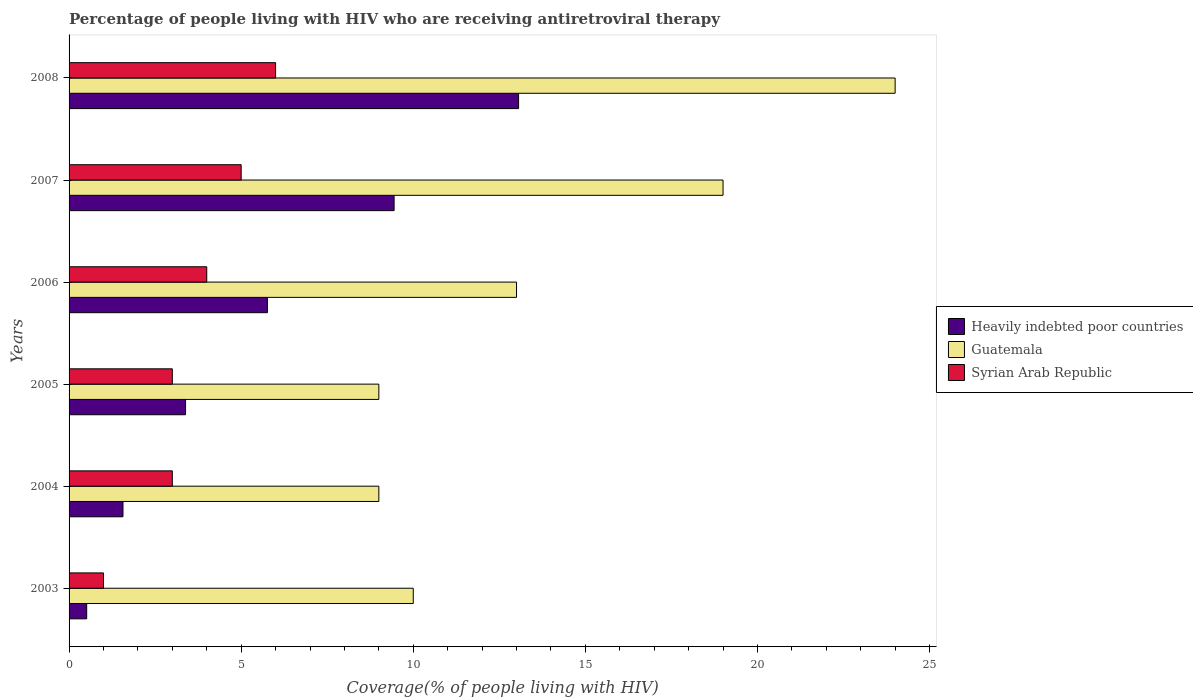How many different coloured bars are there?
Make the answer very short. 3. Are the number of bars per tick equal to the number of legend labels?
Ensure brevity in your answer.  Yes. Are the number of bars on each tick of the Y-axis equal?
Provide a succinct answer. Yes. How many bars are there on the 3rd tick from the top?
Your answer should be compact. 3. In how many cases, is the number of bars for a given year not equal to the number of legend labels?
Offer a terse response. 0. What is the percentage of the HIV infected people who are receiving antiretroviral therapy in Guatemala in 2004?
Keep it short and to the point. 9. Across all years, what is the maximum percentage of the HIV infected people who are receiving antiretroviral therapy in Heavily indebted poor countries?
Keep it short and to the point. 13.06. Across all years, what is the minimum percentage of the HIV infected people who are receiving antiretroviral therapy in Heavily indebted poor countries?
Offer a terse response. 0.51. In which year was the percentage of the HIV infected people who are receiving antiretroviral therapy in Heavily indebted poor countries maximum?
Your answer should be compact. 2008. What is the total percentage of the HIV infected people who are receiving antiretroviral therapy in Syrian Arab Republic in the graph?
Ensure brevity in your answer.  22. What is the difference between the percentage of the HIV infected people who are receiving antiretroviral therapy in Syrian Arab Republic in 2003 and that in 2004?
Offer a very short reply. -2. What is the difference between the percentage of the HIV infected people who are receiving antiretroviral therapy in Guatemala in 2005 and the percentage of the HIV infected people who are receiving antiretroviral therapy in Syrian Arab Republic in 2003?
Your answer should be very brief. 8. What is the average percentage of the HIV infected people who are receiving antiretroviral therapy in Guatemala per year?
Your answer should be compact. 14. In the year 2003, what is the difference between the percentage of the HIV infected people who are receiving antiretroviral therapy in Heavily indebted poor countries and percentage of the HIV infected people who are receiving antiretroviral therapy in Guatemala?
Offer a very short reply. -9.49. In how many years, is the percentage of the HIV infected people who are receiving antiretroviral therapy in Syrian Arab Republic greater than 21 %?
Your response must be concise. 0. What is the ratio of the percentage of the HIV infected people who are receiving antiretroviral therapy in Guatemala in 2006 to that in 2008?
Provide a short and direct response. 0.54. Is the percentage of the HIV infected people who are receiving antiretroviral therapy in Guatemala in 2003 less than that in 2008?
Offer a terse response. Yes. What is the difference between the highest and the second highest percentage of the HIV infected people who are receiving antiretroviral therapy in Heavily indebted poor countries?
Provide a succinct answer. 3.62. What is the difference between the highest and the lowest percentage of the HIV infected people who are receiving antiretroviral therapy in Syrian Arab Republic?
Provide a succinct answer. 5. What does the 1st bar from the top in 2005 represents?
Your response must be concise. Syrian Arab Republic. What does the 1st bar from the bottom in 2004 represents?
Ensure brevity in your answer.  Heavily indebted poor countries. Is it the case that in every year, the sum of the percentage of the HIV infected people who are receiving antiretroviral therapy in Syrian Arab Republic and percentage of the HIV infected people who are receiving antiretroviral therapy in Heavily indebted poor countries is greater than the percentage of the HIV infected people who are receiving antiretroviral therapy in Guatemala?
Make the answer very short. No. How many bars are there?
Provide a succinct answer. 18. Are all the bars in the graph horizontal?
Give a very brief answer. Yes. How many years are there in the graph?
Ensure brevity in your answer.  6. Are the values on the major ticks of X-axis written in scientific E-notation?
Offer a terse response. No. How many legend labels are there?
Provide a succinct answer. 3. What is the title of the graph?
Offer a terse response. Percentage of people living with HIV who are receiving antiretroviral therapy. Does "Paraguay" appear as one of the legend labels in the graph?
Keep it short and to the point. No. What is the label or title of the X-axis?
Your answer should be very brief. Coverage(% of people living with HIV). What is the Coverage(% of people living with HIV) in Heavily indebted poor countries in 2003?
Provide a short and direct response. 0.51. What is the Coverage(% of people living with HIV) of Syrian Arab Republic in 2003?
Offer a terse response. 1. What is the Coverage(% of people living with HIV) of Heavily indebted poor countries in 2004?
Provide a short and direct response. 1.57. What is the Coverage(% of people living with HIV) in Syrian Arab Republic in 2004?
Your answer should be very brief. 3. What is the Coverage(% of people living with HIV) of Heavily indebted poor countries in 2005?
Provide a succinct answer. 3.38. What is the Coverage(% of people living with HIV) in Guatemala in 2005?
Give a very brief answer. 9. What is the Coverage(% of people living with HIV) of Heavily indebted poor countries in 2006?
Keep it short and to the point. 5.76. What is the Coverage(% of people living with HIV) in Guatemala in 2006?
Provide a short and direct response. 13. What is the Coverage(% of people living with HIV) in Syrian Arab Republic in 2006?
Provide a succinct answer. 4. What is the Coverage(% of people living with HIV) in Heavily indebted poor countries in 2007?
Provide a short and direct response. 9.44. What is the Coverage(% of people living with HIV) of Guatemala in 2007?
Your answer should be compact. 19. What is the Coverage(% of people living with HIV) in Heavily indebted poor countries in 2008?
Give a very brief answer. 13.06. What is the Coverage(% of people living with HIV) in Guatemala in 2008?
Make the answer very short. 24. Across all years, what is the maximum Coverage(% of people living with HIV) of Heavily indebted poor countries?
Provide a short and direct response. 13.06. Across all years, what is the maximum Coverage(% of people living with HIV) of Guatemala?
Your answer should be compact. 24. Across all years, what is the minimum Coverage(% of people living with HIV) in Heavily indebted poor countries?
Your response must be concise. 0.51. What is the total Coverage(% of people living with HIV) in Heavily indebted poor countries in the graph?
Your answer should be compact. 33.73. What is the total Coverage(% of people living with HIV) in Guatemala in the graph?
Offer a terse response. 84. What is the total Coverage(% of people living with HIV) in Syrian Arab Republic in the graph?
Provide a short and direct response. 22. What is the difference between the Coverage(% of people living with HIV) of Heavily indebted poor countries in 2003 and that in 2004?
Your answer should be very brief. -1.05. What is the difference between the Coverage(% of people living with HIV) of Guatemala in 2003 and that in 2004?
Make the answer very short. 1. What is the difference between the Coverage(% of people living with HIV) of Syrian Arab Republic in 2003 and that in 2004?
Keep it short and to the point. -2. What is the difference between the Coverage(% of people living with HIV) in Heavily indebted poor countries in 2003 and that in 2005?
Give a very brief answer. -2.87. What is the difference between the Coverage(% of people living with HIV) of Guatemala in 2003 and that in 2005?
Give a very brief answer. 1. What is the difference between the Coverage(% of people living with HIV) of Heavily indebted poor countries in 2003 and that in 2006?
Your response must be concise. -5.25. What is the difference between the Coverage(% of people living with HIV) of Guatemala in 2003 and that in 2006?
Keep it short and to the point. -3. What is the difference between the Coverage(% of people living with HIV) of Heavily indebted poor countries in 2003 and that in 2007?
Your response must be concise. -8.93. What is the difference between the Coverage(% of people living with HIV) in Guatemala in 2003 and that in 2007?
Provide a succinct answer. -9. What is the difference between the Coverage(% of people living with HIV) of Heavily indebted poor countries in 2003 and that in 2008?
Your answer should be very brief. -12.55. What is the difference between the Coverage(% of people living with HIV) in Syrian Arab Republic in 2003 and that in 2008?
Keep it short and to the point. -5. What is the difference between the Coverage(% of people living with HIV) of Heavily indebted poor countries in 2004 and that in 2005?
Make the answer very short. -1.82. What is the difference between the Coverage(% of people living with HIV) in Heavily indebted poor countries in 2004 and that in 2006?
Offer a very short reply. -4.2. What is the difference between the Coverage(% of people living with HIV) of Guatemala in 2004 and that in 2006?
Offer a terse response. -4. What is the difference between the Coverage(% of people living with HIV) in Syrian Arab Republic in 2004 and that in 2006?
Ensure brevity in your answer.  -1. What is the difference between the Coverage(% of people living with HIV) in Heavily indebted poor countries in 2004 and that in 2007?
Your response must be concise. -7.88. What is the difference between the Coverage(% of people living with HIV) of Guatemala in 2004 and that in 2007?
Give a very brief answer. -10. What is the difference between the Coverage(% of people living with HIV) in Heavily indebted poor countries in 2004 and that in 2008?
Offer a terse response. -11.49. What is the difference between the Coverage(% of people living with HIV) of Syrian Arab Republic in 2004 and that in 2008?
Give a very brief answer. -3. What is the difference between the Coverage(% of people living with HIV) in Heavily indebted poor countries in 2005 and that in 2006?
Keep it short and to the point. -2.38. What is the difference between the Coverage(% of people living with HIV) of Guatemala in 2005 and that in 2006?
Give a very brief answer. -4. What is the difference between the Coverage(% of people living with HIV) in Heavily indebted poor countries in 2005 and that in 2007?
Your answer should be very brief. -6.06. What is the difference between the Coverage(% of people living with HIV) in Guatemala in 2005 and that in 2007?
Your answer should be very brief. -10. What is the difference between the Coverage(% of people living with HIV) of Heavily indebted poor countries in 2005 and that in 2008?
Provide a short and direct response. -9.68. What is the difference between the Coverage(% of people living with HIV) in Guatemala in 2005 and that in 2008?
Your answer should be very brief. -15. What is the difference between the Coverage(% of people living with HIV) in Syrian Arab Republic in 2005 and that in 2008?
Offer a terse response. -3. What is the difference between the Coverage(% of people living with HIV) of Heavily indebted poor countries in 2006 and that in 2007?
Ensure brevity in your answer.  -3.68. What is the difference between the Coverage(% of people living with HIV) in Guatemala in 2006 and that in 2007?
Provide a succinct answer. -6. What is the difference between the Coverage(% of people living with HIV) in Heavily indebted poor countries in 2006 and that in 2008?
Provide a succinct answer. -7.3. What is the difference between the Coverage(% of people living with HIV) of Syrian Arab Republic in 2006 and that in 2008?
Your answer should be very brief. -2. What is the difference between the Coverage(% of people living with HIV) of Heavily indebted poor countries in 2007 and that in 2008?
Your response must be concise. -3.62. What is the difference between the Coverage(% of people living with HIV) of Syrian Arab Republic in 2007 and that in 2008?
Your response must be concise. -1. What is the difference between the Coverage(% of people living with HIV) of Heavily indebted poor countries in 2003 and the Coverage(% of people living with HIV) of Guatemala in 2004?
Offer a very short reply. -8.49. What is the difference between the Coverage(% of people living with HIV) of Heavily indebted poor countries in 2003 and the Coverage(% of people living with HIV) of Syrian Arab Republic in 2004?
Give a very brief answer. -2.49. What is the difference between the Coverage(% of people living with HIV) of Heavily indebted poor countries in 2003 and the Coverage(% of people living with HIV) of Guatemala in 2005?
Provide a short and direct response. -8.49. What is the difference between the Coverage(% of people living with HIV) of Heavily indebted poor countries in 2003 and the Coverage(% of people living with HIV) of Syrian Arab Republic in 2005?
Your answer should be very brief. -2.49. What is the difference between the Coverage(% of people living with HIV) of Guatemala in 2003 and the Coverage(% of people living with HIV) of Syrian Arab Republic in 2005?
Provide a succinct answer. 7. What is the difference between the Coverage(% of people living with HIV) in Heavily indebted poor countries in 2003 and the Coverage(% of people living with HIV) in Guatemala in 2006?
Your answer should be very brief. -12.49. What is the difference between the Coverage(% of people living with HIV) in Heavily indebted poor countries in 2003 and the Coverage(% of people living with HIV) in Syrian Arab Republic in 2006?
Provide a succinct answer. -3.49. What is the difference between the Coverage(% of people living with HIV) in Heavily indebted poor countries in 2003 and the Coverage(% of people living with HIV) in Guatemala in 2007?
Your answer should be very brief. -18.49. What is the difference between the Coverage(% of people living with HIV) in Heavily indebted poor countries in 2003 and the Coverage(% of people living with HIV) in Syrian Arab Republic in 2007?
Provide a succinct answer. -4.49. What is the difference between the Coverage(% of people living with HIV) of Guatemala in 2003 and the Coverage(% of people living with HIV) of Syrian Arab Republic in 2007?
Provide a short and direct response. 5. What is the difference between the Coverage(% of people living with HIV) of Heavily indebted poor countries in 2003 and the Coverage(% of people living with HIV) of Guatemala in 2008?
Provide a short and direct response. -23.49. What is the difference between the Coverage(% of people living with HIV) in Heavily indebted poor countries in 2003 and the Coverage(% of people living with HIV) in Syrian Arab Republic in 2008?
Your answer should be very brief. -5.49. What is the difference between the Coverage(% of people living with HIV) of Guatemala in 2003 and the Coverage(% of people living with HIV) of Syrian Arab Republic in 2008?
Make the answer very short. 4. What is the difference between the Coverage(% of people living with HIV) of Heavily indebted poor countries in 2004 and the Coverage(% of people living with HIV) of Guatemala in 2005?
Ensure brevity in your answer.  -7.43. What is the difference between the Coverage(% of people living with HIV) in Heavily indebted poor countries in 2004 and the Coverage(% of people living with HIV) in Syrian Arab Republic in 2005?
Your answer should be very brief. -1.43. What is the difference between the Coverage(% of people living with HIV) in Guatemala in 2004 and the Coverage(% of people living with HIV) in Syrian Arab Republic in 2005?
Provide a short and direct response. 6. What is the difference between the Coverage(% of people living with HIV) in Heavily indebted poor countries in 2004 and the Coverage(% of people living with HIV) in Guatemala in 2006?
Provide a short and direct response. -11.43. What is the difference between the Coverage(% of people living with HIV) in Heavily indebted poor countries in 2004 and the Coverage(% of people living with HIV) in Syrian Arab Republic in 2006?
Your answer should be compact. -2.43. What is the difference between the Coverage(% of people living with HIV) in Heavily indebted poor countries in 2004 and the Coverage(% of people living with HIV) in Guatemala in 2007?
Provide a short and direct response. -17.43. What is the difference between the Coverage(% of people living with HIV) of Heavily indebted poor countries in 2004 and the Coverage(% of people living with HIV) of Syrian Arab Republic in 2007?
Ensure brevity in your answer.  -3.43. What is the difference between the Coverage(% of people living with HIV) of Heavily indebted poor countries in 2004 and the Coverage(% of people living with HIV) of Guatemala in 2008?
Your answer should be compact. -22.43. What is the difference between the Coverage(% of people living with HIV) in Heavily indebted poor countries in 2004 and the Coverage(% of people living with HIV) in Syrian Arab Republic in 2008?
Your answer should be compact. -4.43. What is the difference between the Coverage(% of people living with HIV) of Heavily indebted poor countries in 2005 and the Coverage(% of people living with HIV) of Guatemala in 2006?
Provide a short and direct response. -9.62. What is the difference between the Coverage(% of people living with HIV) of Heavily indebted poor countries in 2005 and the Coverage(% of people living with HIV) of Syrian Arab Republic in 2006?
Provide a short and direct response. -0.62. What is the difference between the Coverage(% of people living with HIV) of Heavily indebted poor countries in 2005 and the Coverage(% of people living with HIV) of Guatemala in 2007?
Provide a succinct answer. -15.62. What is the difference between the Coverage(% of people living with HIV) in Heavily indebted poor countries in 2005 and the Coverage(% of people living with HIV) in Syrian Arab Republic in 2007?
Offer a terse response. -1.62. What is the difference between the Coverage(% of people living with HIV) of Heavily indebted poor countries in 2005 and the Coverage(% of people living with HIV) of Guatemala in 2008?
Offer a terse response. -20.62. What is the difference between the Coverage(% of people living with HIV) of Heavily indebted poor countries in 2005 and the Coverage(% of people living with HIV) of Syrian Arab Republic in 2008?
Your response must be concise. -2.62. What is the difference between the Coverage(% of people living with HIV) of Guatemala in 2005 and the Coverage(% of people living with HIV) of Syrian Arab Republic in 2008?
Make the answer very short. 3. What is the difference between the Coverage(% of people living with HIV) in Heavily indebted poor countries in 2006 and the Coverage(% of people living with HIV) in Guatemala in 2007?
Offer a very short reply. -13.24. What is the difference between the Coverage(% of people living with HIV) of Heavily indebted poor countries in 2006 and the Coverage(% of people living with HIV) of Syrian Arab Republic in 2007?
Provide a short and direct response. 0.76. What is the difference between the Coverage(% of people living with HIV) of Heavily indebted poor countries in 2006 and the Coverage(% of people living with HIV) of Guatemala in 2008?
Offer a very short reply. -18.24. What is the difference between the Coverage(% of people living with HIV) in Heavily indebted poor countries in 2006 and the Coverage(% of people living with HIV) in Syrian Arab Republic in 2008?
Provide a succinct answer. -0.24. What is the difference between the Coverage(% of people living with HIV) of Guatemala in 2006 and the Coverage(% of people living with HIV) of Syrian Arab Republic in 2008?
Your answer should be compact. 7. What is the difference between the Coverage(% of people living with HIV) of Heavily indebted poor countries in 2007 and the Coverage(% of people living with HIV) of Guatemala in 2008?
Ensure brevity in your answer.  -14.56. What is the difference between the Coverage(% of people living with HIV) of Heavily indebted poor countries in 2007 and the Coverage(% of people living with HIV) of Syrian Arab Republic in 2008?
Offer a very short reply. 3.44. What is the average Coverage(% of people living with HIV) in Heavily indebted poor countries per year?
Keep it short and to the point. 5.62. What is the average Coverage(% of people living with HIV) of Syrian Arab Republic per year?
Offer a very short reply. 3.67. In the year 2003, what is the difference between the Coverage(% of people living with HIV) in Heavily indebted poor countries and Coverage(% of people living with HIV) in Guatemala?
Ensure brevity in your answer.  -9.49. In the year 2003, what is the difference between the Coverage(% of people living with HIV) of Heavily indebted poor countries and Coverage(% of people living with HIV) of Syrian Arab Republic?
Give a very brief answer. -0.49. In the year 2003, what is the difference between the Coverage(% of people living with HIV) in Guatemala and Coverage(% of people living with HIV) in Syrian Arab Republic?
Make the answer very short. 9. In the year 2004, what is the difference between the Coverage(% of people living with HIV) of Heavily indebted poor countries and Coverage(% of people living with HIV) of Guatemala?
Your answer should be very brief. -7.43. In the year 2004, what is the difference between the Coverage(% of people living with HIV) in Heavily indebted poor countries and Coverage(% of people living with HIV) in Syrian Arab Republic?
Provide a succinct answer. -1.43. In the year 2004, what is the difference between the Coverage(% of people living with HIV) of Guatemala and Coverage(% of people living with HIV) of Syrian Arab Republic?
Offer a terse response. 6. In the year 2005, what is the difference between the Coverage(% of people living with HIV) in Heavily indebted poor countries and Coverage(% of people living with HIV) in Guatemala?
Provide a short and direct response. -5.62. In the year 2005, what is the difference between the Coverage(% of people living with HIV) in Heavily indebted poor countries and Coverage(% of people living with HIV) in Syrian Arab Republic?
Your answer should be very brief. 0.38. In the year 2005, what is the difference between the Coverage(% of people living with HIV) of Guatemala and Coverage(% of people living with HIV) of Syrian Arab Republic?
Make the answer very short. 6. In the year 2006, what is the difference between the Coverage(% of people living with HIV) of Heavily indebted poor countries and Coverage(% of people living with HIV) of Guatemala?
Provide a short and direct response. -7.24. In the year 2006, what is the difference between the Coverage(% of people living with HIV) in Heavily indebted poor countries and Coverage(% of people living with HIV) in Syrian Arab Republic?
Provide a succinct answer. 1.76. In the year 2007, what is the difference between the Coverage(% of people living with HIV) in Heavily indebted poor countries and Coverage(% of people living with HIV) in Guatemala?
Offer a terse response. -9.56. In the year 2007, what is the difference between the Coverage(% of people living with HIV) of Heavily indebted poor countries and Coverage(% of people living with HIV) of Syrian Arab Republic?
Give a very brief answer. 4.44. In the year 2008, what is the difference between the Coverage(% of people living with HIV) of Heavily indebted poor countries and Coverage(% of people living with HIV) of Guatemala?
Give a very brief answer. -10.94. In the year 2008, what is the difference between the Coverage(% of people living with HIV) in Heavily indebted poor countries and Coverage(% of people living with HIV) in Syrian Arab Republic?
Give a very brief answer. 7.06. What is the ratio of the Coverage(% of people living with HIV) in Heavily indebted poor countries in 2003 to that in 2004?
Your response must be concise. 0.33. What is the ratio of the Coverage(% of people living with HIV) in Syrian Arab Republic in 2003 to that in 2004?
Make the answer very short. 0.33. What is the ratio of the Coverage(% of people living with HIV) of Heavily indebted poor countries in 2003 to that in 2005?
Give a very brief answer. 0.15. What is the ratio of the Coverage(% of people living with HIV) of Guatemala in 2003 to that in 2005?
Offer a terse response. 1.11. What is the ratio of the Coverage(% of people living with HIV) of Heavily indebted poor countries in 2003 to that in 2006?
Ensure brevity in your answer.  0.09. What is the ratio of the Coverage(% of people living with HIV) in Guatemala in 2003 to that in 2006?
Provide a short and direct response. 0.77. What is the ratio of the Coverage(% of people living with HIV) in Syrian Arab Republic in 2003 to that in 2006?
Provide a succinct answer. 0.25. What is the ratio of the Coverage(% of people living with HIV) in Heavily indebted poor countries in 2003 to that in 2007?
Provide a short and direct response. 0.05. What is the ratio of the Coverage(% of people living with HIV) in Guatemala in 2003 to that in 2007?
Offer a very short reply. 0.53. What is the ratio of the Coverage(% of people living with HIV) in Heavily indebted poor countries in 2003 to that in 2008?
Give a very brief answer. 0.04. What is the ratio of the Coverage(% of people living with HIV) of Guatemala in 2003 to that in 2008?
Provide a short and direct response. 0.42. What is the ratio of the Coverage(% of people living with HIV) of Syrian Arab Republic in 2003 to that in 2008?
Provide a short and direct response. 0.17. What is the ratio of the Coverage(% of people living with HIV) of Heavily indebted poor countries in 2004 to that in 2005?
Offer a terse response. 0.46. What is the ratio of the Coverage(% of people living with HIV) of Guatemala in 2004 to that in 2005?
Keep it short and to the point. 1. What is the ratio of the Coverage(% of people living with HIV) in Syrian Arab Republic in 2004 to that in 2005?
Provide a succinct answer. 1. What is the ratio of the Coverage(% of people living with HIV) in Heavily indebted poor countries in 2004 to that in 2006?
Keep it short and to the point. 0.27. What is the ratio of the Coverage(% of people living with HIV) of Guatemala in 2004 to that in 2006?
Offer a terse response. 0.69. What is the ratio of the Coverage(% of people living with HIV) of Heavily indebted poor countries in 2004 to that in 2007?
Your answer should be compact. 0.17. What is the ratio of the Coverage(% of people living with HIV) in Guatemala in 2004 to that in 2007?
Keep it short and to the point. 0.47. What is the ratio of the Coverage(% of people living with HIV) in Syrian Arab Republic in 2004 to that in 2007?
Provide a succinct answer. 0.6. What is the ratio of the Coverage(% of people living with HIV) of Heavily indebted poor countries in 2004 to that in 2008?
Your answer should be very brief. 0.12. What is the ratio of the Coverage(% of people living with HIV) of Guatemala in 2004 to that in 2008?
Make the answer very short. 0.38. What is the ratio of the Coverage(% of people living with HIV) in Syrian Arab Republic in 2004 to that in 2008?
Offer a very short reply. 0.5. What is the ratio of the Coverage(% of people living with HIV) in Heavily indebted poor countries in 2005 to that in 2006?
Make the answer very short. 0.59. What is the ratio of the Coverage(% of people living with HIV) of Guatemala in 2005 to that in 2006?
Your response must be concise. 0.69. What is the ratio of the Coverage(% of people living with HIV) of Heavily indebted poor countries in 2005 to that in 2007?
Keep it short and to the point. 0.36. What is the ratio of the Coverage(% of people living with HIV) in Guatemala in 2005 to that in 2007?
Offer a very short reply. 0.47. What is the ratio of the Coverage(% of people living with HIV) of Heavily indebted poor countries in 2005 to that in 2008?
Make the answer very short. 0.26. What is the ratio of the Coverage(% of people living with HIV) of Guatemala in 2005 to that in 2008?
Offer a very short reply. 0.38. What is the ratio of the Coverage(% of people living with HIV) of Heavily indebted poor countries in 2006 to that in 2007?
Offer a very short reply. 0.61. What is the ratio of the Coverage(% of people living with HIV) in Guatemala in 2006 to that in 2007?
Provide a short and direct response. 0.68. What is the ratio of the Coverage(% of people living with HIV) in Syrian Arab Republic in 2006 to that in 2007?
Keep it short and to the point. 0.8. What is the ratio of the Coverage(% of people living with HIV) of Heavily indebted poor countries in 2006 to that in 2008?
Offer a terse response. 0.44. What is the ratio of the Coverage(% of people living with HIV) of Guatemala in 2006 to that in 2008?
Your response must be concise. 0.54. What is the ratio of the Coverage(% of people living with HIV) of Syrian Arab Republic in 2006 to that in 2008?
Provide a succinct answer. 0.67. What is the ratio of the Coverage(% of people living with HIV) in Heavily indebted poor countries in 2007 to that in 2008?
Your answer should be compact. 0.72. What is the ratio of the Coverage(% of people living with HIV) in Guatemala in 2007 to that in 2008?
Provide a short and direct response. 0.79. What is the ratio of the Coverage(% of people living with HIV) of Syrian Arab Republic in 2007 to that in 2008?
Provide a short and direct response. 0.83. What is the difference between the highest and the second highest Coverage(% of people living with HIV) in Heavily indebted poor countries?
Provide a short and direct response. 3.62. What is the difference between the highest and the lowest Coverage(% of people living with HIV) in Heavily indebted poor countries?
Make the answer very short. 12.55. What is the difference between the highest and the lowest Coverage(% of people living with HIV) in Syrian Arab Republic?
Your answer should be compact. 5. 